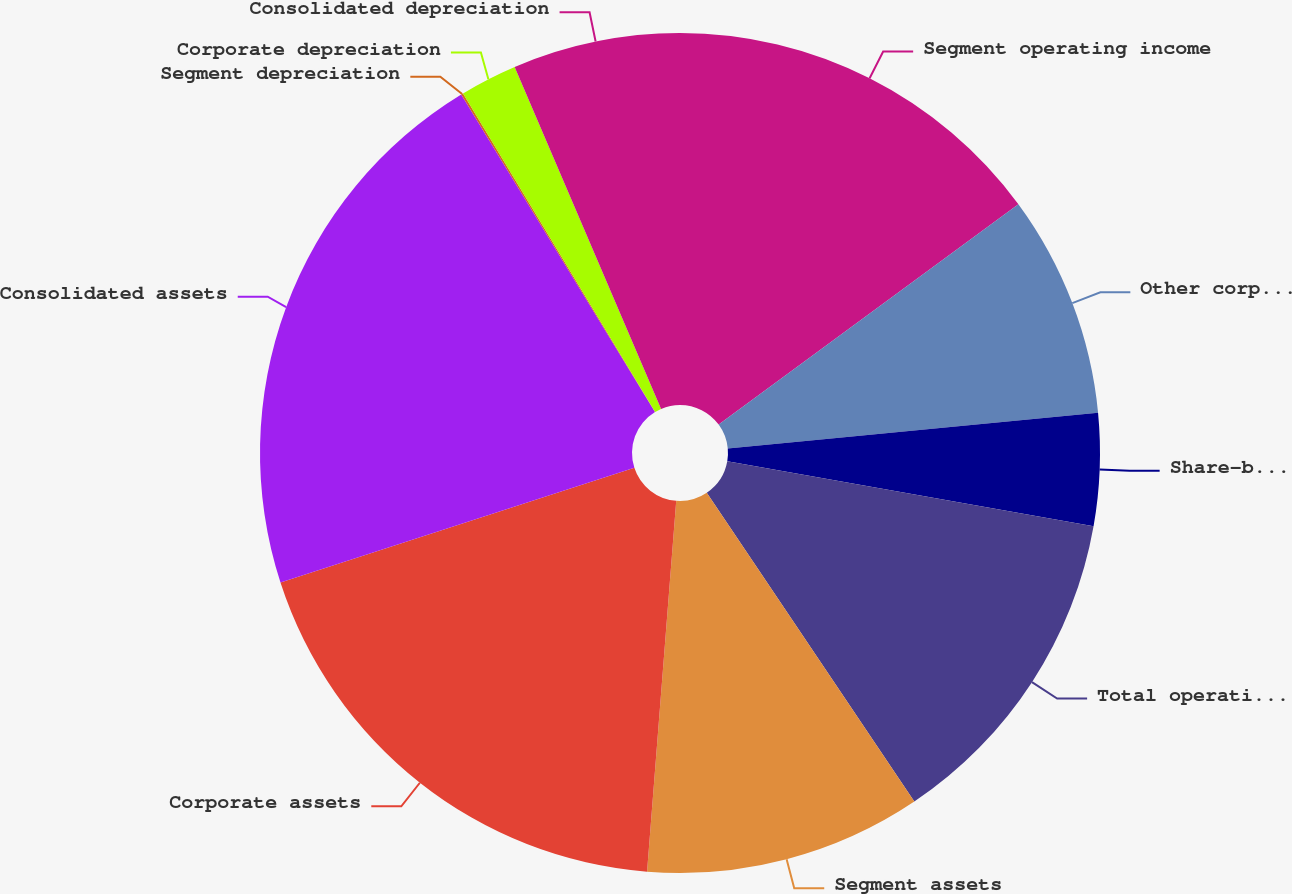<chart> <loc_0><loc_0><loc_500><loc_500><pie_chart><fcel>Segment operating income<fcel>Other corporate expenses net<fcel>Share-based compensation<fcel>Total operating income<fcel>Segment assets<fcel>Corporate assets<fcel>Consolidated assets<fcel>Segment depreciation<fcel>Corporate depreciation<fcel>Consolidated depreciation<nl><fcel>14.91%<fcel>8.56%<fcel>4.32%<fcel>12.79%<fcel>10.67%<fcel>18.76%<fcel>21.27%<fcel>0.08%<fcel>2.2%<fcel>6.44%<nl></chart> 